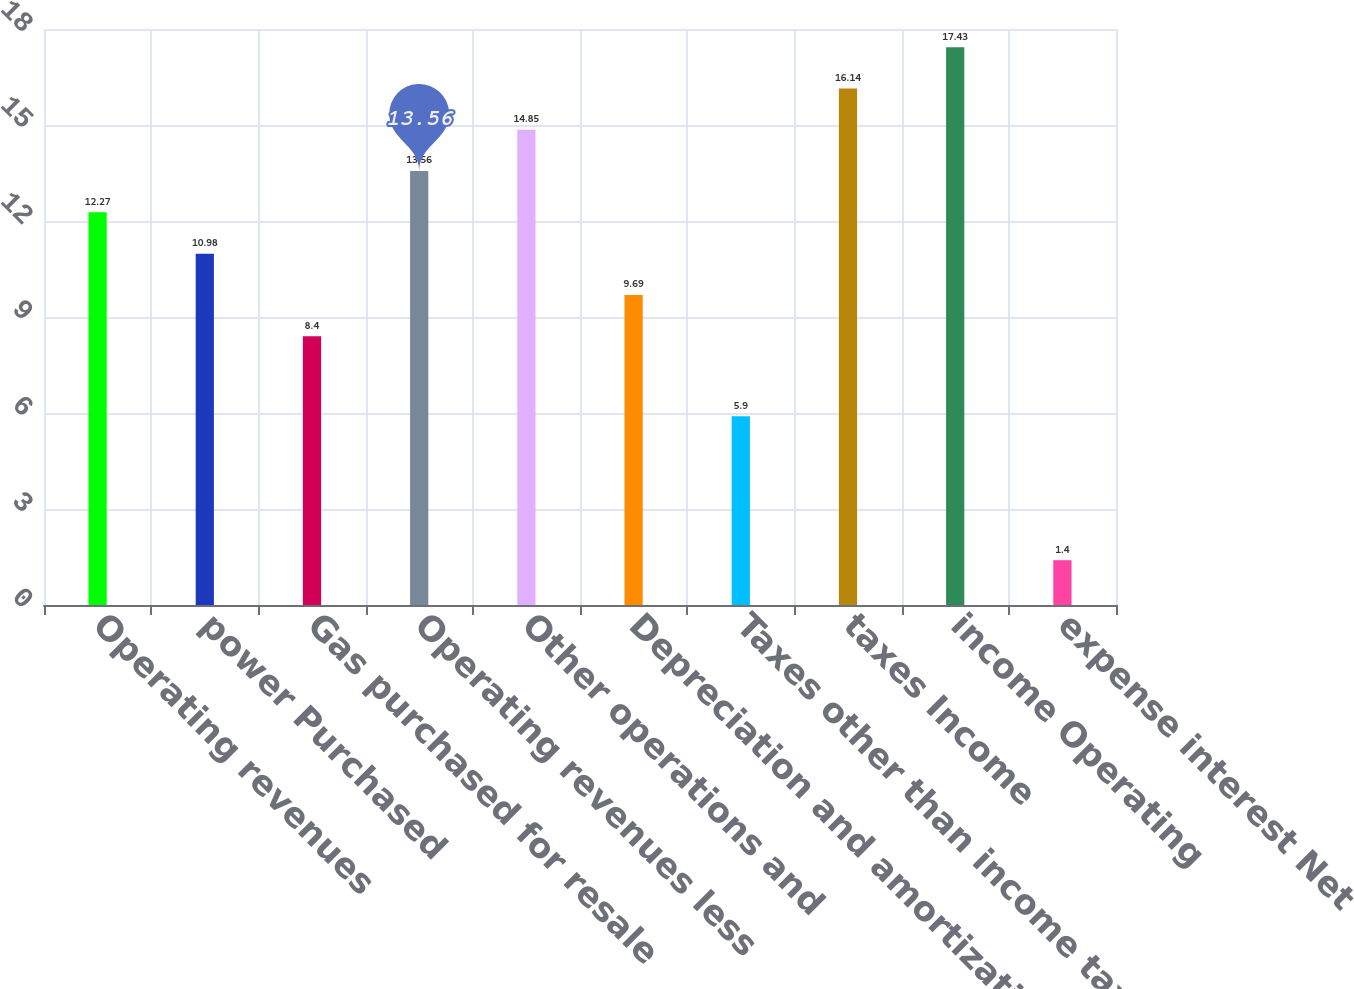Convert chart. <chart><loc_0><loc_0><loc_500><loc_500><bar_chart><fcel>Operating revenues<fcel>power Purchased<fcel>Gas purchased for resale<fcel>Operating revenues less<fcel>Other operations and<fcel>Depreciation and amortization<fcel>Taxes other than income taxes<fcel>taxes Income<fcel>income Operating<fcel>expense interest Net<nl><fcel>12.27<fcel>10.98<fcel>8.4<fcel>13.56<fcel>14.85<fcel>9.69<fcel>5.9<fcel>16.14<fcel>17.43<fcel>1.4<nl></chart> 